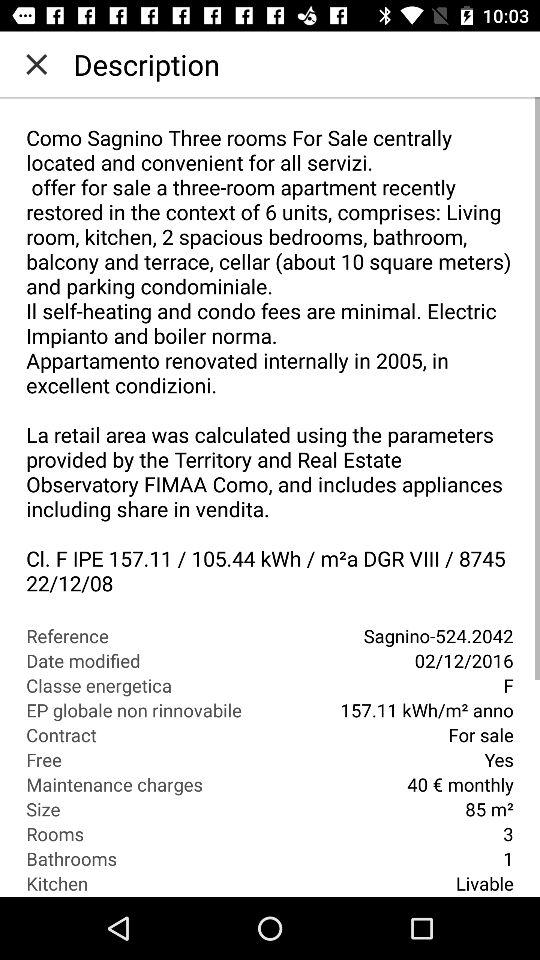What is the reference number? The reference number is 524.2042. 